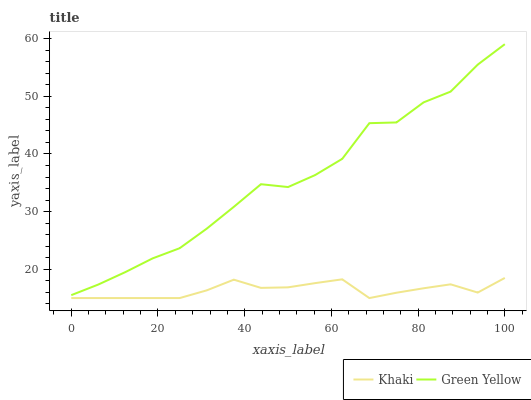Does Khaki have the minimum area under the curve?
Answer yes or no. Yes. Does Green Yellow have the maximum area under the curve?
Answer yes or no. Yes. Does Khaki have the maximum area under the curve?
Answer yes or no. No. Is Khaki the smoothest?
Answer yes or no. Yes. Is Green Yellow the roughest?
Answer yes or no. Yes. Is Khaki the roughest?
Answer yes or no. No. Does Khaki have the lowest value?
Answer yes or no. Yes. Does Green Yellow have the highest value?
Answer yes or no. Yes. Does Khaki have the highest value?
Answer yes or no. No. Is Khaki less than Green Yellow?
Answer yes or no. Yes. Is Green Yellow greater than Khaki?
Answer yes or no. Yes. Does Khaki intersect Green Yellow?
Answer yes or no. No. 